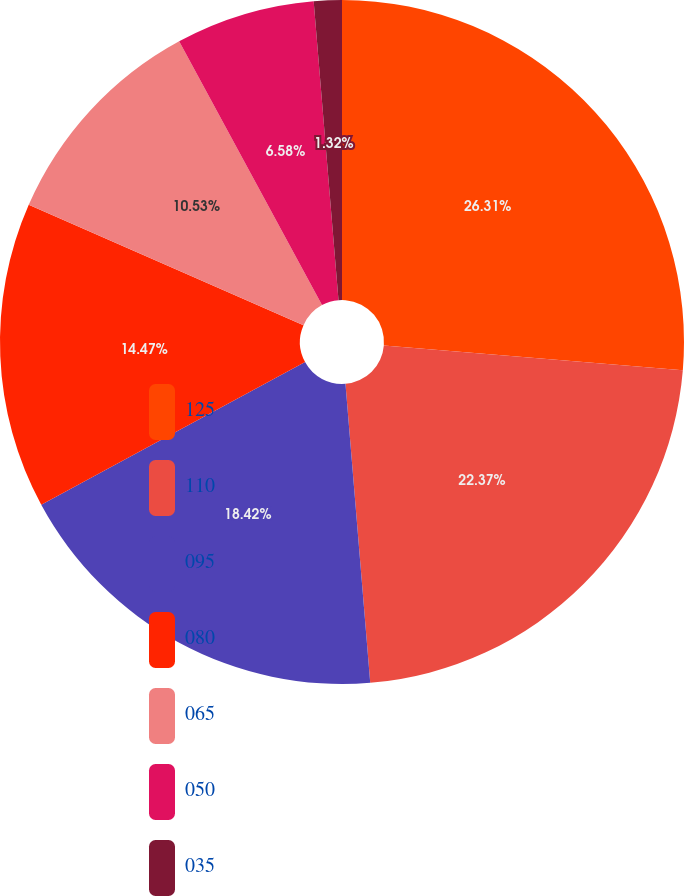Convert chart. <chart><loc_0><loc_0><loc_500><loc_500><pie_chart><fcel>125<fcel>110<fcel>095<fcel>080<fcel>065<fcel>050<fcel>035<nl><fcel>26.32%<fcel>22.37%<fcel>18.42%<fcel>14.47%<fcel>10.53%<fcel>6.58%<fcel>1.32%<nl></chart> 